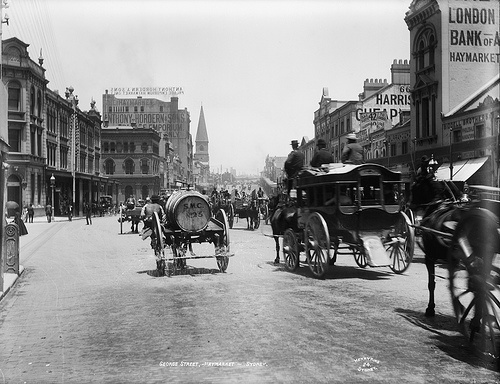Describe the objects in this image and their specific colors. I can see horse in darkgray, black, gray, and lightgray tones, horse in darkgray, black, gray, and lightgray tones, people in darkgray, black, gray, and lightgray tones, people in darkgray, gray, black, and lightgray tones, and people in darkgray, black, gray, and lightgray tones in this image. 